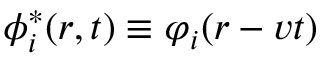Convert formula to latex. <formula><loc_0><loc_0><loc_500><loc_500>\phi _ { i } ^ { * } ( r , t ) \equiv \varphi _ { i } ( r - v t )</formula> 